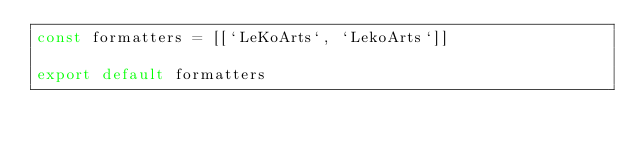<code> <loc_0><loc_0><loc_500><loc_500><_TypeScript_>const formatters = [[`LeKoArts`, `LekoArts`]]

export default formatters
</code> 